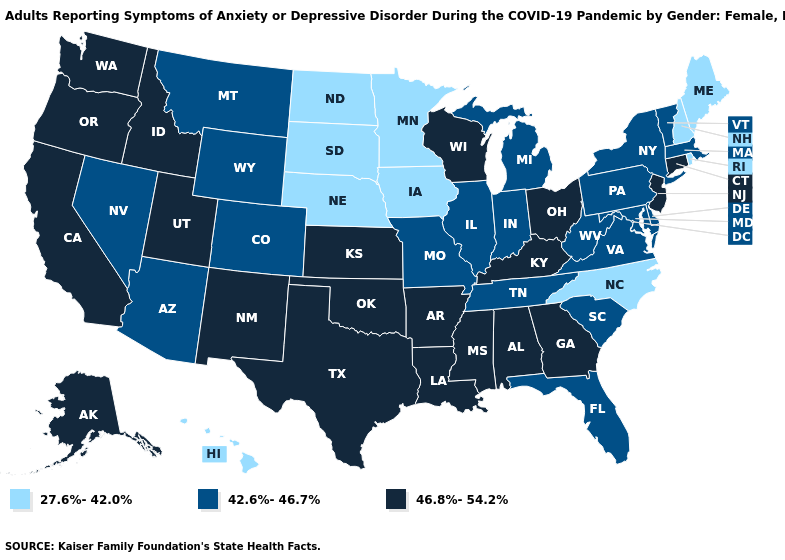Among the states that border Wisconsin , does Michigan have the highest value?
Short answer required. Yes. Among the states that border Minnesota , does North Dakota have the highest value?
Answer briefly. No. Which states have the lowest value in the Northeast?
Answer briefly. Maine, New Hampshire, Rhode Island. Does Idaho have the lowest value in the West?
Keep it brief. No. Among the states that border California , does Arizona have the lowest value?
Give a very brief answer. Yes. Among the states that border New Hampshire , does Maine have the highest value?
Keep it brief. No. What is the lowest value in states that border Rhode Island?
Quick response, please. 42.6%-46.7%. What is the highest value in the USA?
Give a very brief answer. 46.8%-54.2%. Which states have the highest value in the USA?
Short answer required. Alabama, Alaska, Arkansas, California, Connecticut, Georgia, Idaho, Kansas, Kentucky, Louisiana, Mississippi, New Jersey, New Mexico, Ohio, Oklahoma, Oregon, Texas, Utah, Washington, Wisconsin. Name the states that have a value in the range 27.6%-42.0%?
Give a very brief answer. Hawaii, Iowa, Maine, Minnesota, Nebraska, New Hampshire, North Carolina, North Dakota, Rhode Island, South Dakota. Name the states that have a value in the range 42.6%-46.7%?
Keep it brief. Arizona, Colorado, Delaware, Florida, Illinois, Indiana, Maryland, Massachusetts, Michigan, Missouri, Montana, Nevada, New York, Pennsylvania, South Carolina, Tennessee, Vermont, Virginia, West Virginia, Wyoming. What is the value of Alaska?
Give a very brief answer. 46.8%-54.2%. Name the states that have a value in the range 27.6%-42.0%?
Answer briefly. Hawaii, Iowa, Maine, Minnesota, Nebraska, New Hampshire, North Carolina, North Dakota, Rhode Island, South Dakota. What is the value of Wyoming?
Concise answer only. 42.6%-46.7%. 